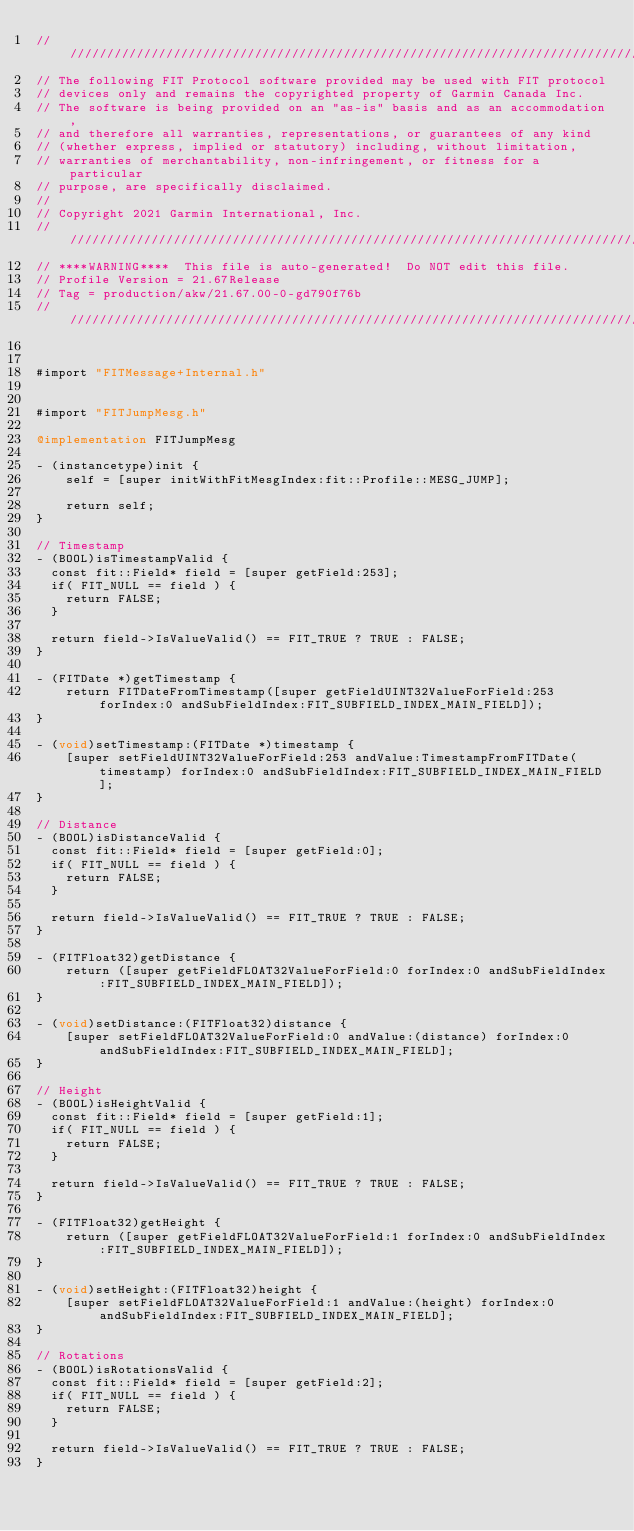<code> <loc_0><loc_0><loc_500><loc_500><_ObjectiveC_>////////////////////////////////////////////////////////////////////////////////
// The following FIT Protocol software provided may be used with FIT protocol
// devices only and remains the copyrighted property of Garmin Canada Inc.
// The software is being provided on an "as-is" basis and as an accommodation,
// and therefore all warranties, representations, or guarantees of any kind
// (whether express, implied or statutory) including, without limitation,
// warranties of merchantability, non-infringement, or fitness for a particular
// purpose, are specifically disclaimed.
//
// Copyright 2021 Garmin International, Inc.
////////////////////////////////////////////////////////////////////////////////
// ****WARNING****  This file is auto-generated!  Do NOT edit this file.
// Profile Version = 21.67Release
// Tag = production/akw/21.67.00-0-gd790f76b
////////////////////////////////////////////////////////////////////////////////


#import "FITMessage+Internal.h"


#import "FITJumpMesg.h"

@implementation FITJumpMesg

- (instancetype)init {
    self = [super initWithFitMesgIndex:fit::Profile::MESG_JUMP];

    return self;
}

// Timestamp 
- (BOOL)isTimestampValid {
	const fit::Field* field = [super getField:253];
	if( FIT_NULL == field ) {
		return FALSE;
	}

	return field->IsValueValid() == FIT_TRUE ? TRUE : FALSE;
}

- (FITDate *)getTimestamp {
    return FITDateFromTimestamp([super getFieldUINT32ValueForField:253 forIndex:0 andSubFieldIndex:FIT_SUBFIELD_INDEX_MAIN_FIELD]);
}

- (void)setTimestamp:(FITDate *)timestamp {
    [super setFieldUINT32ValueForField:253 andValue:TimestampFromFITDate(timestamp) forIndex:0 andSubFieldIndex:FIT_SUBFIELD_INDEX_MAIN_FIELD];
} 

// Distance 
- (BOOL)isDistanceValid {
	const fit::Field* field = [super getField:0];
	if( FIT_NULL == field ) {
		return FALSE;
	}

	return field->IsValueValid() == FIT_TRUE ? TRUE : FALSE;
}

- (FITFloat32)getDistance {
    return ([super getFieldFLOAT32ValueForField:0 forIndex:0 andSubFieldIndex:FIT_SUBFIELD_INDEX_MAIN_FIELD]);
}

- (void)setDistance:(FITFloat32)distance {
    [super setFieldFLOAT32ValueForField:0 andValue:(distance) forIndex:0 andSubFieldIndex:FIT_SUBFIELD_INDEX_MAIN_FIELD];
} 

// Height 
- (BOOL)isHeightValid {
	const fit::Field* field = [super getField:1];
	if( FIT_NULL == field ) {
		return FALSE;
	}

	return field->IsValueValid() == FIT_TRUE ? TRUE : FALSE;
}

- (FITFloat32)getHeight {
    return ([super getFieldFLOAT32ValueForField:1 forIndex:0 andSubFieldIndex:FIT_SUBFIELD_INDEX_MAIN_FIELD]);
}

- (void)setHeight:(FITFloat32)height {
    [super setFieldFLOAT32ValueForField:1 andValue:(height) forIndex:0 andSubFieldIndex:FIT_SUBFIELD_INDEX_MAIN_FIELD];
} 

// Rotations 
- (BOOL)isRotationsValid {
	const fit::Field* field = [super getField:2];
	if( FIT_NULL == field ) {
		return FALSE;
	}

	return field->IsValueValid() == FIT_TRUE ? TRUE : FALSE;
}
</code> 